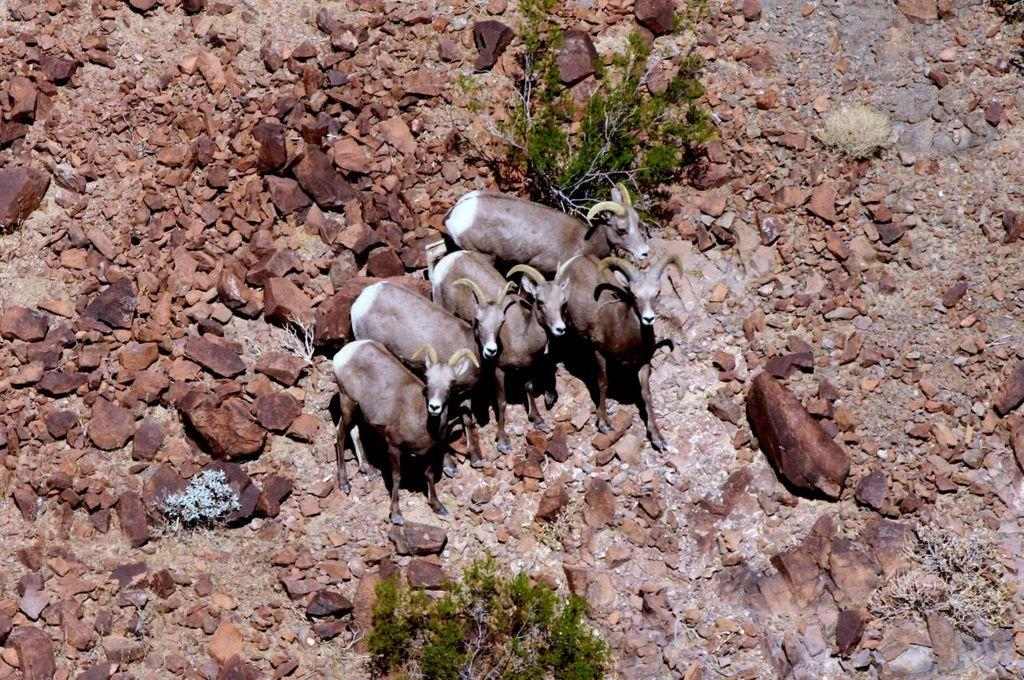What types of living organisms can be seen in the image? There are animals in the image. What natural elements are present in the image? There are trees and rocks on the ground in the image. What type of tooth can be seen in the image? There is no tooth present in the image. How comfortable are the animals in the image? The comfort level of the animals cannot be determined from the image alone. 